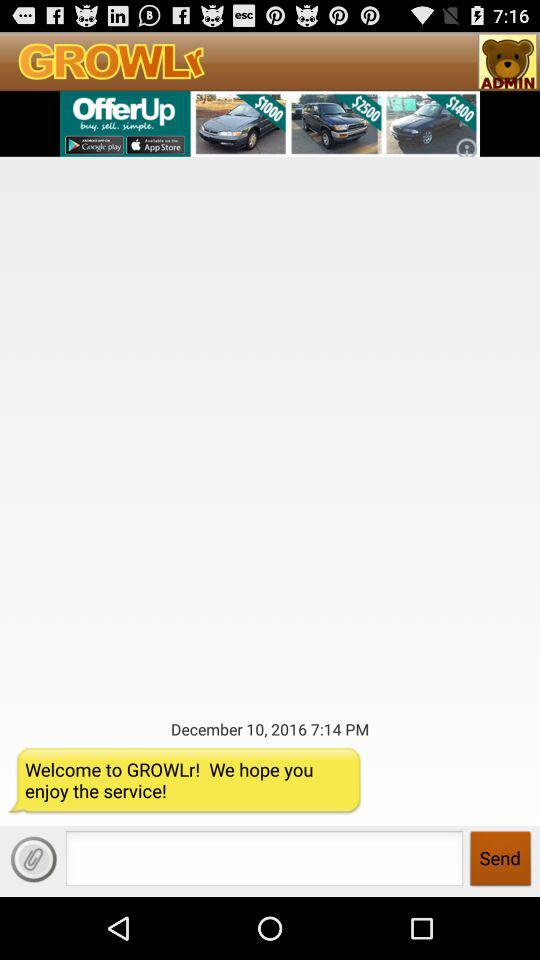What is the date? The date is December 10, 2016. 